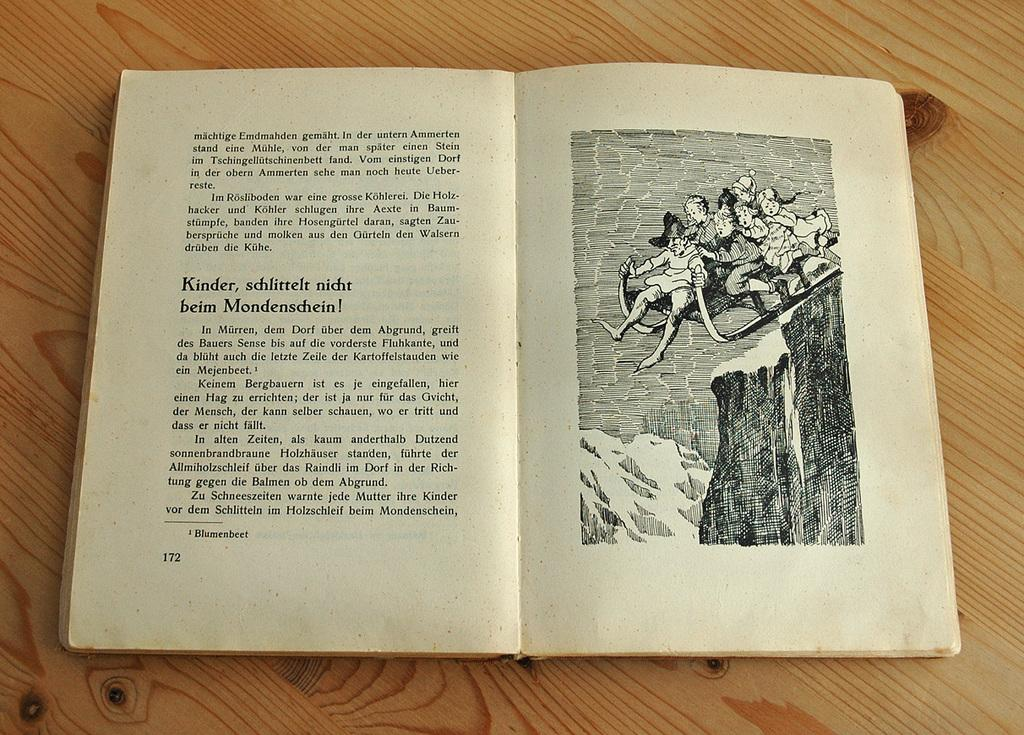<image>
Write a terse but informative summary of the picture. An open book with German text on one page and a picture of several children falling off a mountain on a sled on the other. 